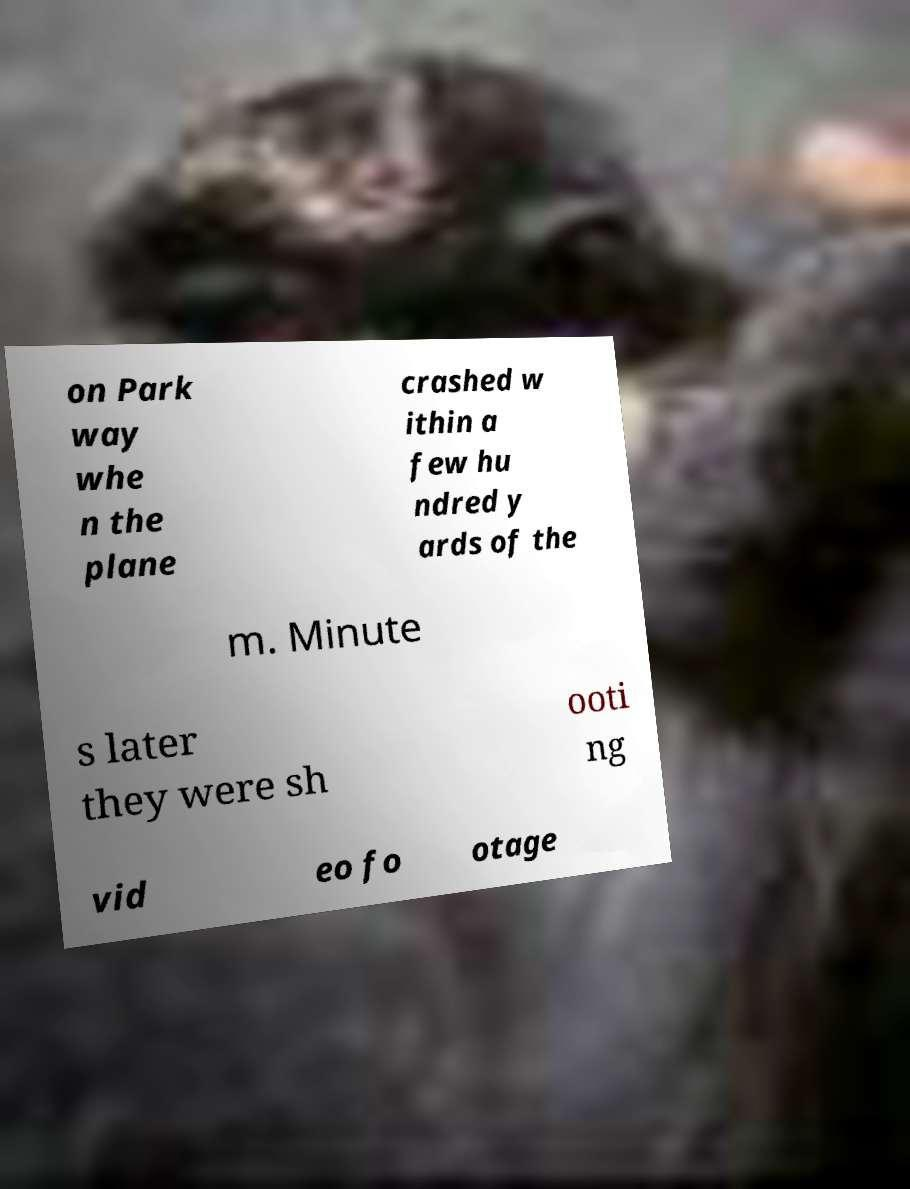I need the written content from this picture converted into text. Can you do that? on Park way whe n the plane crashed w ithin a few hu ndred y ards of the m. Minute s later they were sh ooti ng vid eo fo otage 